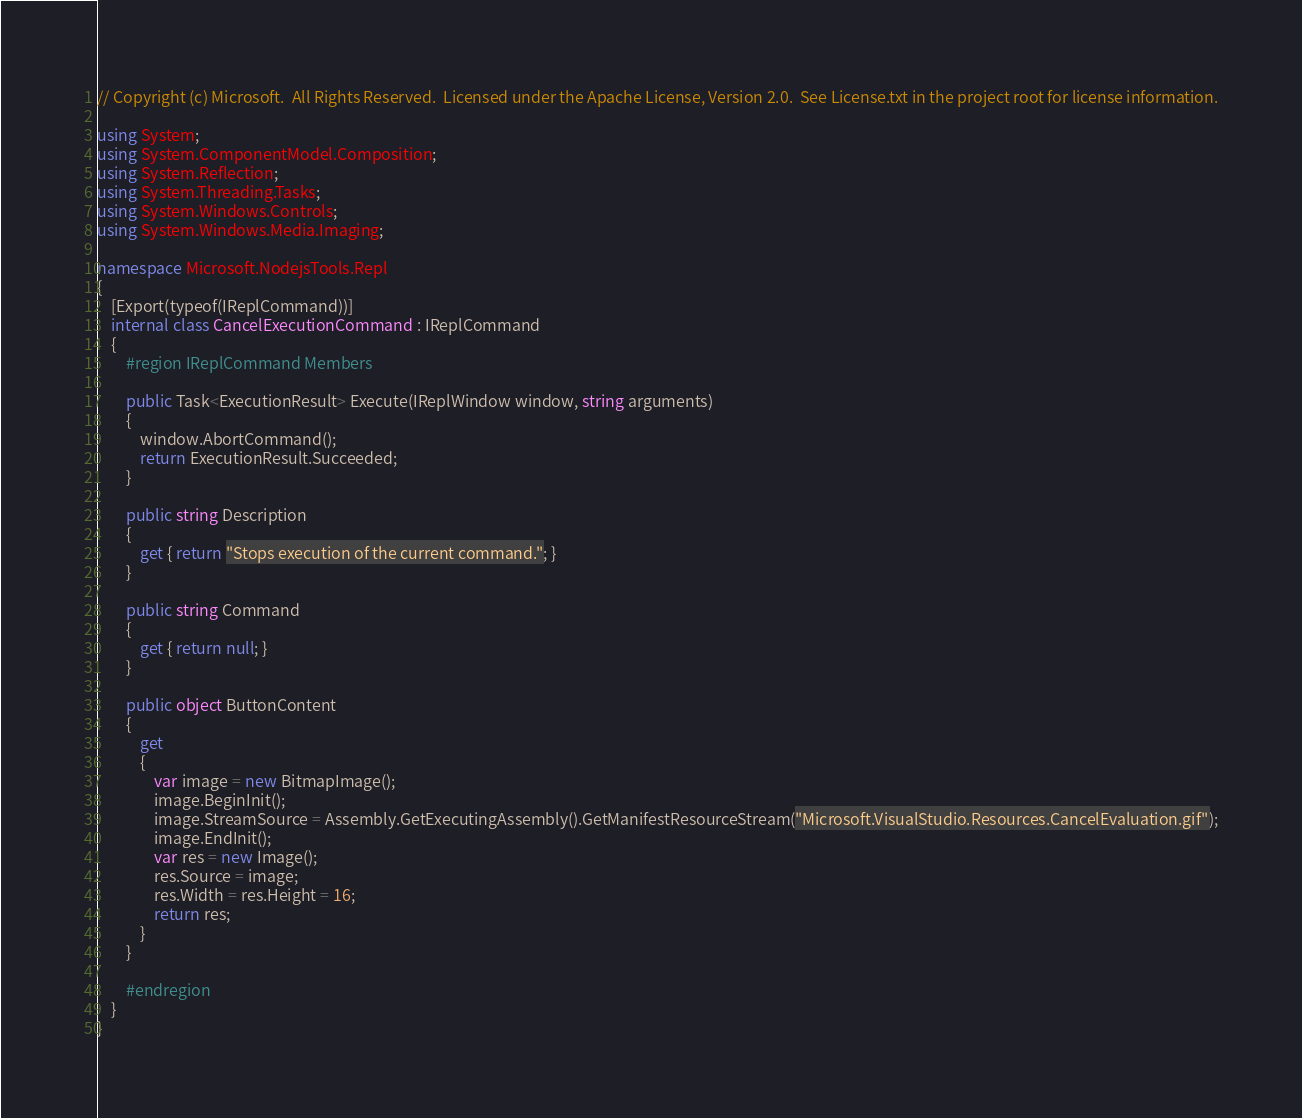Convert code to text. <code><loc_0><loc_0><loc_500><loc_500><_C#_>// Copyright (c) Microsoft.  All Rights Reserved.  Licensed under the Apache License, Version 2.0.  See License.txt in the project root for license information.

using System;
using System.ComponentModel.Composition;
using System.Reflection;
using System.Threading.Tasks;
using System.Windows.Controls;
using System.Windows.Media.Imaging;

namespace Microsoft.NodejsTools.Repl
{
    [Export(typeof(IReplCommand))]
    internal class CancelExecutionCommand : IReplCommand
    {
        #region IReplCommand Members

        public Task<ExecutionResult> Execute(IReplWindow window, string arguments)
        {
            window.AbortCommand();
            return ExecutionResult.Succeeded;
        }

        public string Description
        {
            get { return "Stops execution of the current command."; }
        }

        public string Command
        {
            get { return null; }
        }

        public object ButtonContent
        {
            get
            {
                var image = new BitmapImage();
                image.BeginInit();
                image.StreamSource = Assembly.GetExecutingAssembly().GetManifestResourceStream("Microsoft.VisualStudio.Resources.CancelEvaluation.gif");
                image.EndInit();
                var res = new Image();
                res.Source = image;
                res.Width = res.Height = 16;
                return res;
            }
        }

        #endregion
    }
}
</code> 